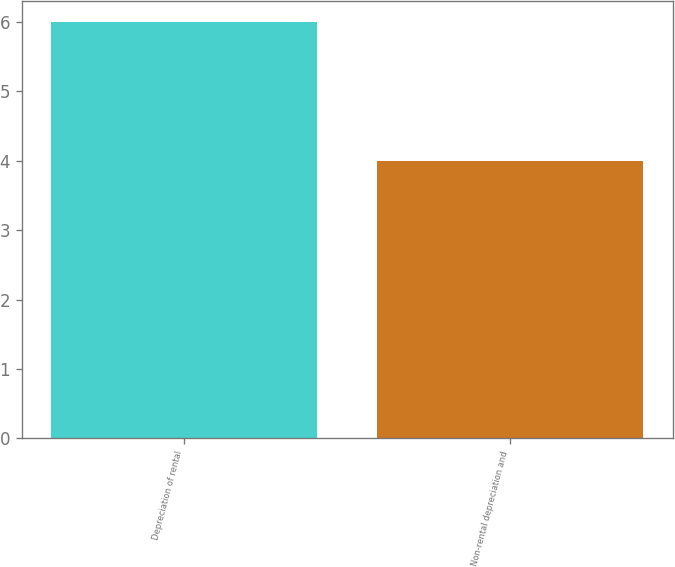Convert chart. <chart><loc_0><loc_0><loc_500><loc_500><bar_chart><fcel>Depreciation of rental<fcel>Non-rental depreciation and<nl><fcel>6<fcel>4<nl></chart> 